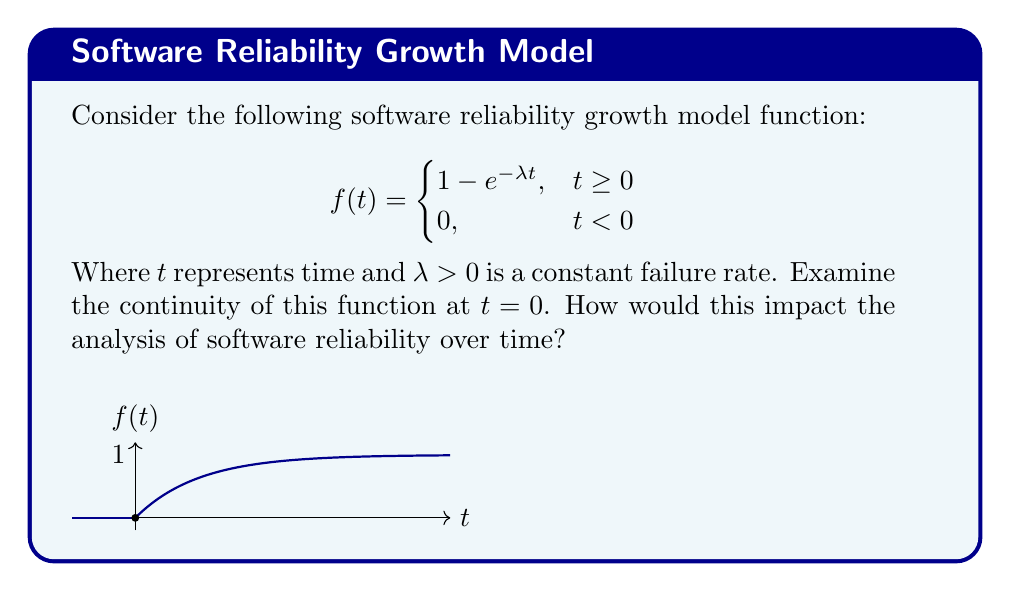Help me with this question. To examine the continuity of the function at $t = 0$, we need to check if the following three conditions are met:

1. $f(0)$ exists
2. $\lim_{t \to 0^-} f(t)$ exists
3. $\lim_{t \to 0^+} f(t)$ exists
4. All three values are equal

Step 1: Evaluate $f(0)$
$$f(0) = 1 - e^{-\lambda \cdot 0} = 1 - 1 = 0$$

Step 2: Evaluate $\lim_{t \to 0^-} f(t)$
For $t < 0$, $f(t) = 0$
$$\lim_{t \to 0^-} f(t) = 0$$

Step 3: Evaluate $\lim_{t \to 0^+} f(t)$
For $t > 0$, $f(t) = 1 - e^{-\lambda t}$
$$\lim_{t \to 0^+} f(t) = \lim_{t \to 0^+} (1 - e^{-\lambda t}) = 1 - e^0 = 0$$

Step 4: Compare the results
We see that:
$$f(0) = \lim_{t \to 0^-} f(t) = \lim_{t \to 0^+} f(t) = 0$$

Therefore, the function is continuous at $t = 0$.

Impact on software reliability analysis:
The continuity of this function at $t = 0$ ensures a smooth transition between the initial state (no failures) and the reliability growth phase. This allows for consistent and uninterrupted analysis of software reliability over time, particularly at the crucial point where testing or operation begins.
Answer: The function is continuous at $t = 0$, allowing for smooth analysis of software reliability growth from the start of testing or operation. 